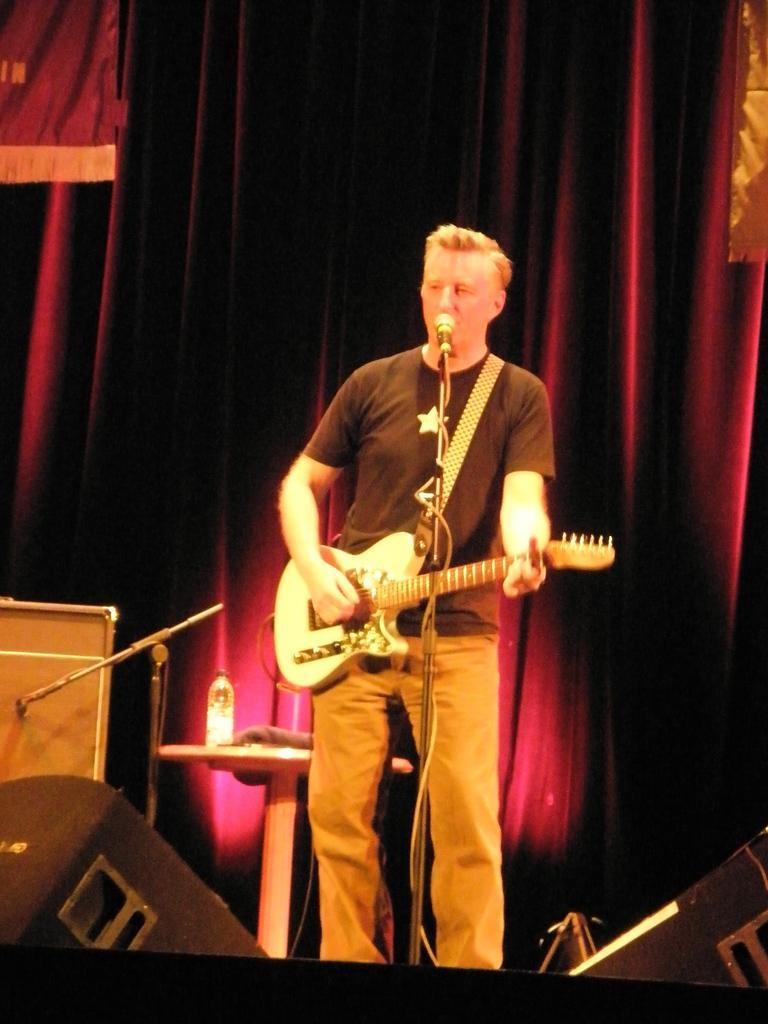In one or two sentences, can you explain what this image depicts? Here we can see a man is standing and singing, and holding a guitar in his hands, and in front here is the microphone and stand, and at back here is the table and some objects on it, and here is the curtain. 